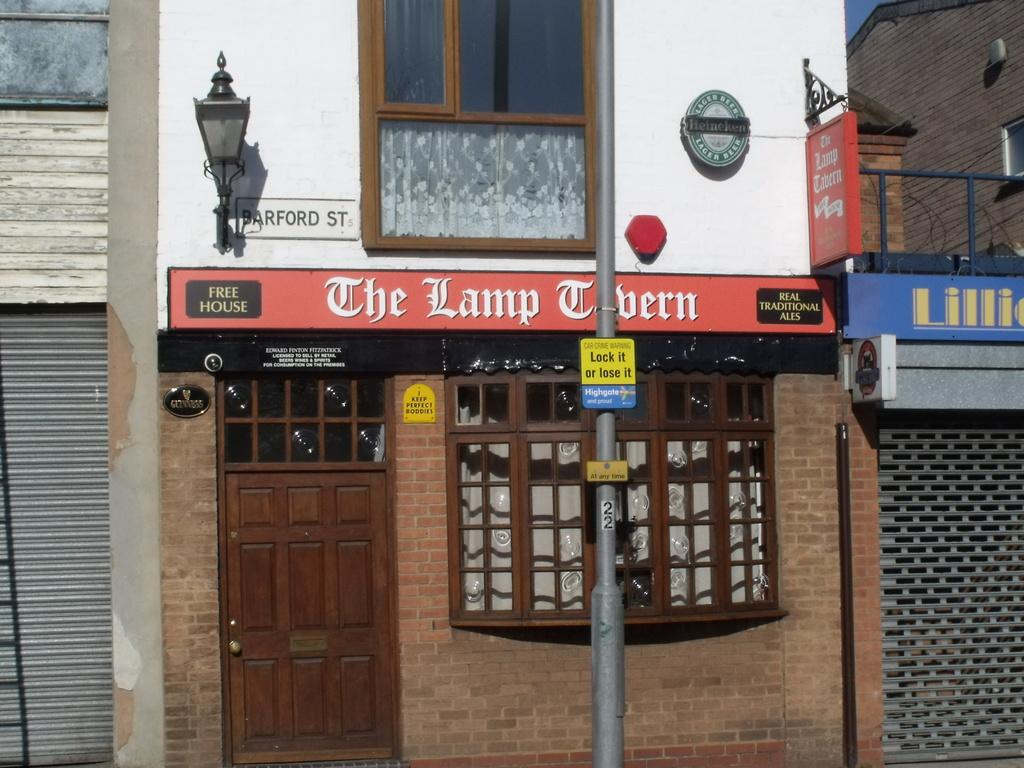What type of structures are present in the image? There are buildings in the image. What features can be seen on the buildings? The buildings have windows and doors. What is attached to the wall in the image? There are boards on the wall and a lamp on the wall. What type of signs are present in the image? There are sign boards on poles. What type of behavior can be observed in the farmer's territory in the image? There is no farmer or territory present in the image; it features buildings, boards, a lamp, and sign boards. 